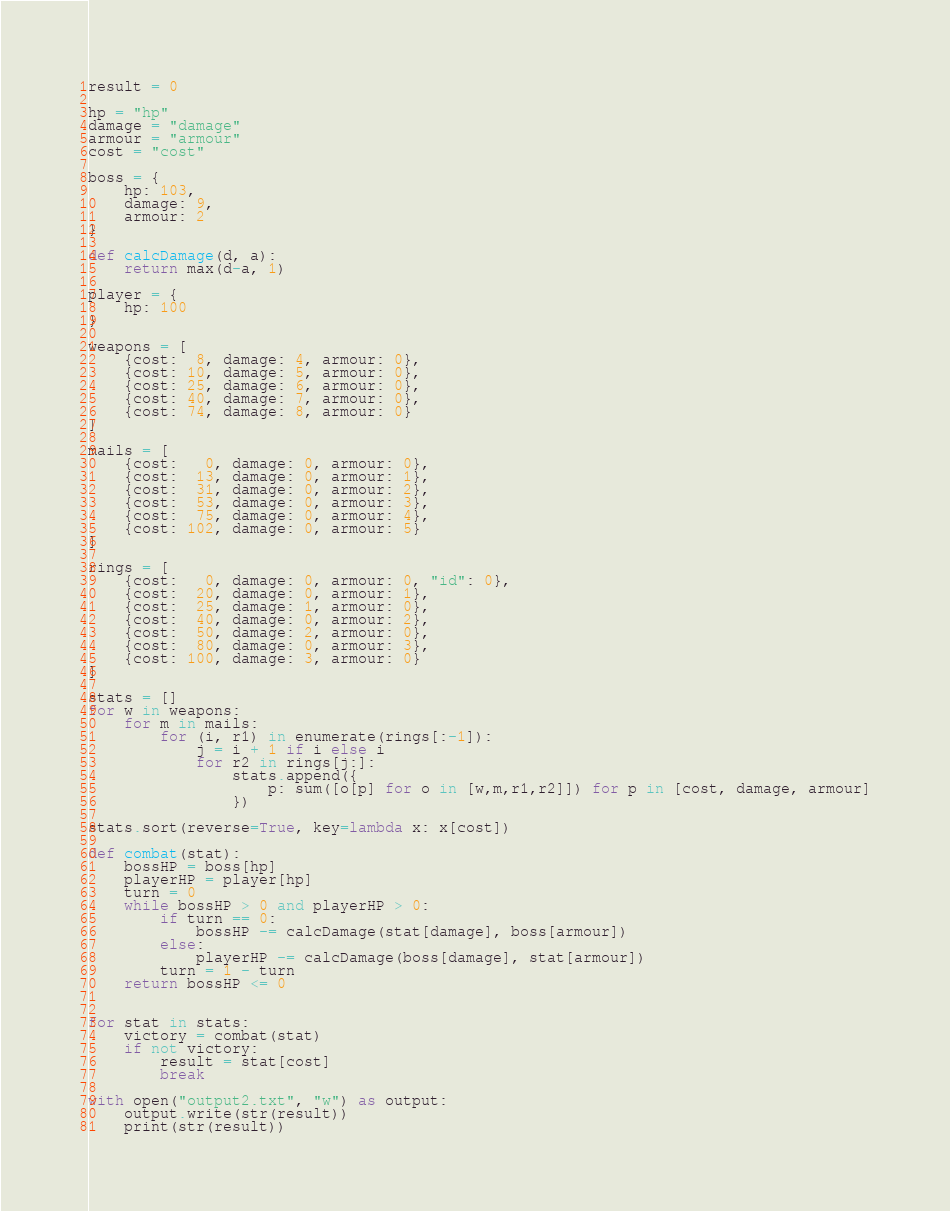<code> <loc_0><loc_0><loc_500><loc_500><_Python_>result = 0

hp = "hp"
damage = "damage"
armour = "armour"
cost = "cost"

boss = {
    hp: 103,
    damage: 9,
    armour: 2
}

def calcDamage(d, a):
    return max(d-a, 1)

player = {
    hp: 100
}

weapons = [
    {cost:  8, damage: 4, armour: 0},
    {cost: 10, damage: 5, armour: 0},
    {cost: 25, damage: 6, armour: 0},
    {cost: 40, damage: 7, armour: 0},
    {cost: 74, damage: 8, armour: 0}
]

mails = [
    {cost:   0, damage: 0, armour: 0},
    {cost:  13, damage: 0, armour: 1},
    {cost:  31, damage: 0, armour: 2},
    {cost:  53, damage: 0, armour: 3},
    {cost:  75, damage: 0, armour: 4},
    {cost: 102, damage: 0, armour: 5}
]

rings = [
    {cost:   0, damage: 0, armour: 0, "id": 0},
    {cost:  20, damage: 0, armour: 1},
    {cost:  25, damage: 1, armour: 0},
    {cost:  40, damage: 0, armour: 2},
    {cost:  50, damage: 2, armour: 0},
    {cost:  80, damage: 0, armour: 3},
    {cost: 100, damage: 3, armour: 0}
]

stats = []
for w in weapons:
    for m in mails:
        for (i, r1) in enumerate(rings[:-1]):
            j = i + 1 if i else i
            for r2 in rings[j:]:
                stats.append({
                    p: sum([o[p] for o in [w,m,r1,r2]]) for p in [cost, damage, armour]
                })

stats.sort(reverse=True, key=lambda x: x[cost])

def combat(stat):
    bossHP = boss[hp]
    playerHP = player[hp]
    turn = 0
    while bossHP > 0 and playerHP > 0:
        if turn == 0:
            bossHP -= calcDamage(stat[damage], boss[armour])
        else:
            playerHP -= calcDamage(boss[damage], stat[armour])
        turn = 1 - turn
    return bossHP <= 0


for stat in stats:
    victory = combat(stat)
    if not victory:
        result = stat[cost]
        break

with open("output2.txt", "w") as output:
    output.write(str(result))
    print(str(result))

</code> 